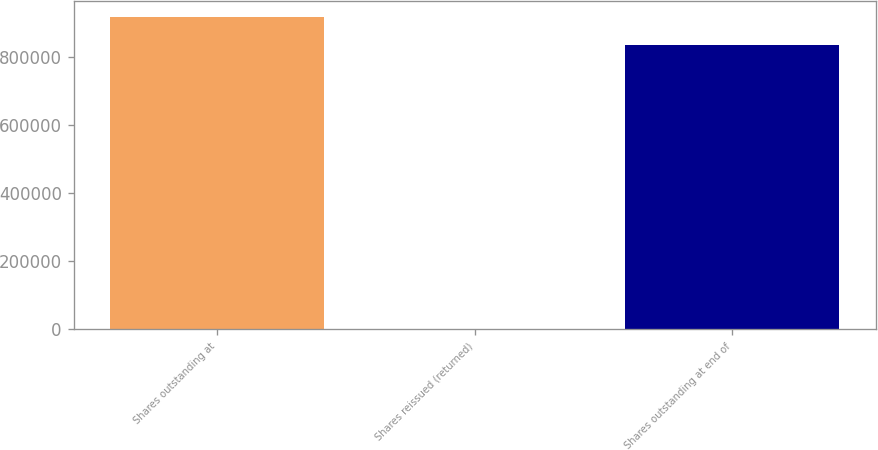Convert chart. <chart><loc_0><loc_0><loc_500><loc_500><bar_chart><fcel>Shares outstanding at<fcel>Shares reissued (returned)<fcel>Shares outstanding at end of<nl><fcel>919640<fcel>63<fcel>835285<nl></chart> 